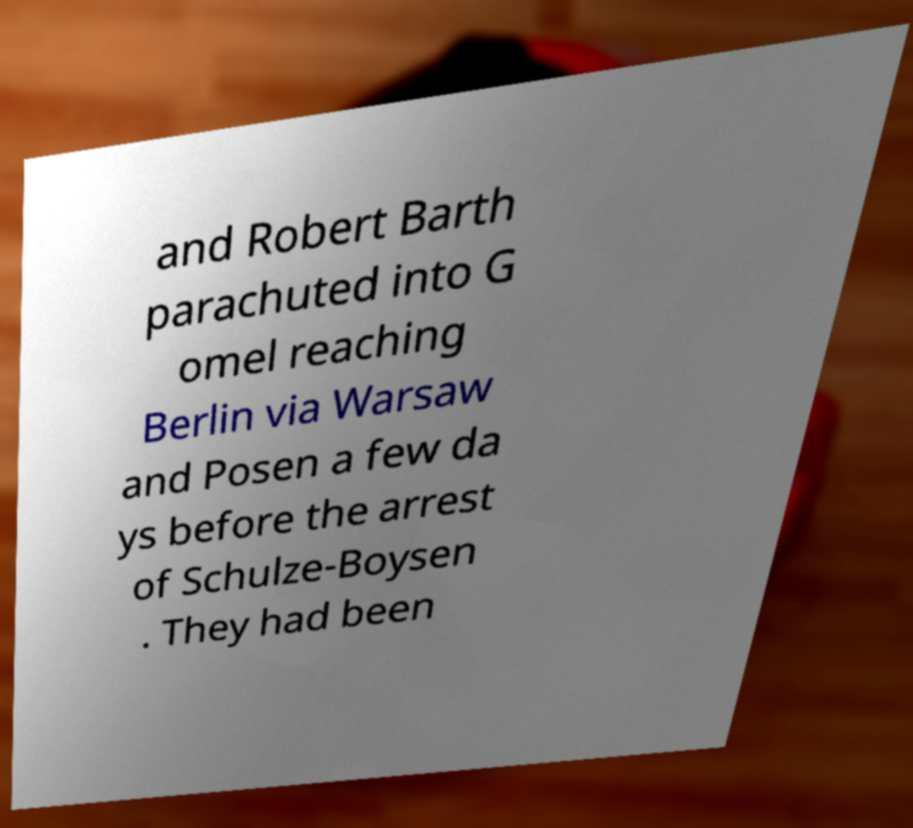Could you extract and type out the text from this image? and Robert Barth parachuted into G omel reaching Berlin via Warsaw and Posen a few da ys before the arrest of Schulze-Boysen . They had been 